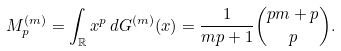<formula> <loc_0><loc_0><loc_500><loc_500>M ^ { ( m ) } _ { p } = \int _ { \mathbb { R } } { x ^ { p } \, d G ^ { ( m ) } ( x ) } = \frac { 1 } { m p + 1 } \binom { p m + p } { p } .</formula> 